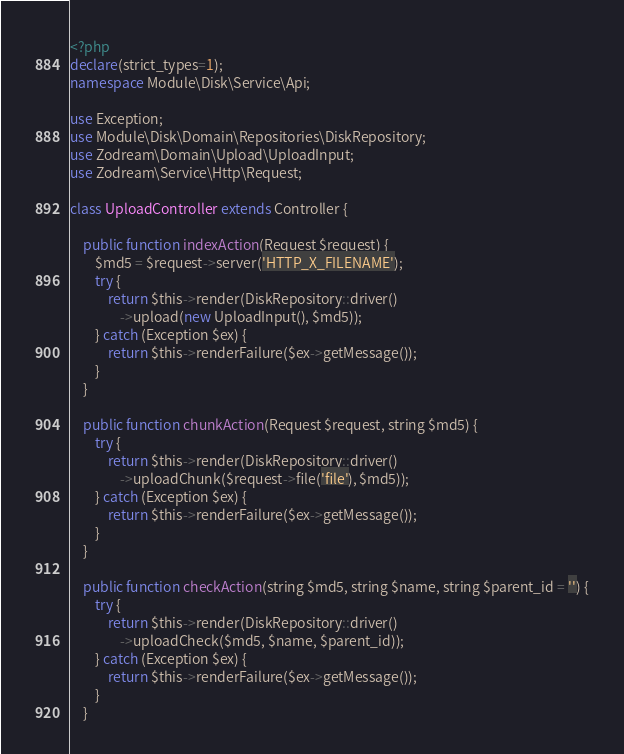Convert code to text. <code><loc_0><loc_0><loc_500><loc_500><_PHP_><?php
declare(strict_types=1);
namespace Module\Disk\Service\Api;

use Exception;
use Module\Disk\Domain\Repositories\DiskRepository;
use Zodream\Domain\Upload\UploadInput;
use Zodream\Service\Http\Request;

class UploadController extends Controller {
    
    public function indexAction(Request $request) {
        $md5 = $request->server('HTTP_X_FILENAME');
        try {
            return $this->render(DiskRepository::driver()
                ->upload(new UploadInput(), $md5));
        } catch (Exception $ex) {
            return $this->renderFailure($ex->getMessage());
        }
    }

    public function chunkAction(Request $request, string $md5) {
        try {
            return $this->render(DiskRepository::driver()
                ->uploadChunk($request->file('file'), $md5));
        } catch (Exception $ex) {
            return $this->renderFailure($ex->getMessage());
        }
    }

    public function checkAction(string $md5, string $name, string $parent_id = '') {
        try {
            return $this->render(DiskRepository::driver()
                ->uploadCheck($md5, $name, $parent_id));
        } catch (Exception $ex) {
            return $this->renderFailure($ex->getMessage());
        }
    }
</code> 